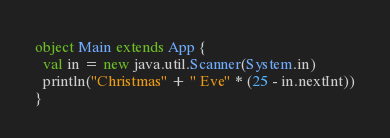Convert code to text. <code><loc_0><loc_0><loc_500><loc_500><_Scala_>object Main extends App {
  val in = new java.util.Scanner(System.in)
  println("Christmas" + " Eve" * (25 - in.nextInt))
}</code> 